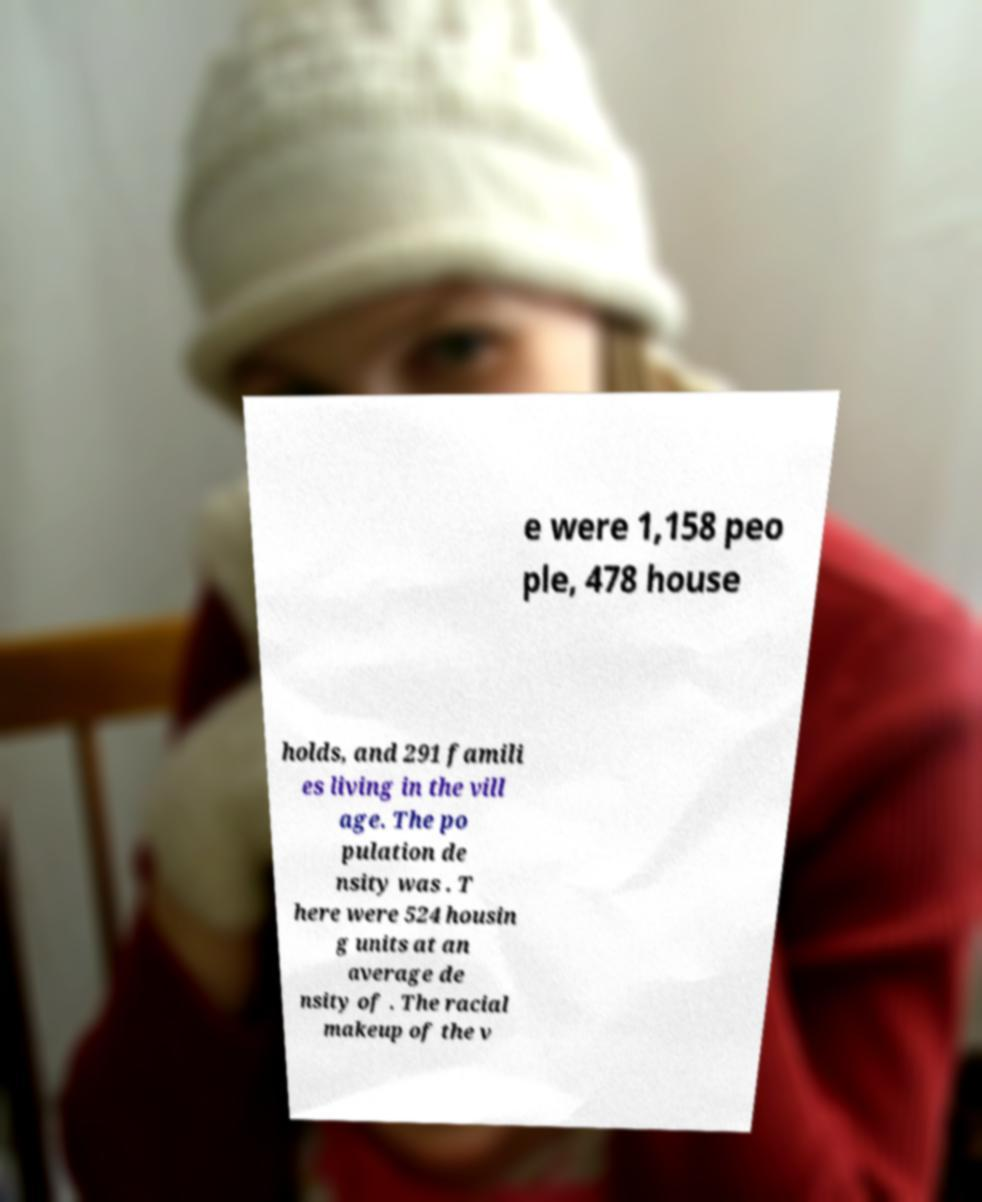Can you accurately transcribe the text from the provided image for me? e were 1,158 peo ple, 478 house holds, and 291 famili es living in the vill age. The po pulation de nsity was . T here were 524 housin g units at an average de nsity of . The racial makeup of the v 